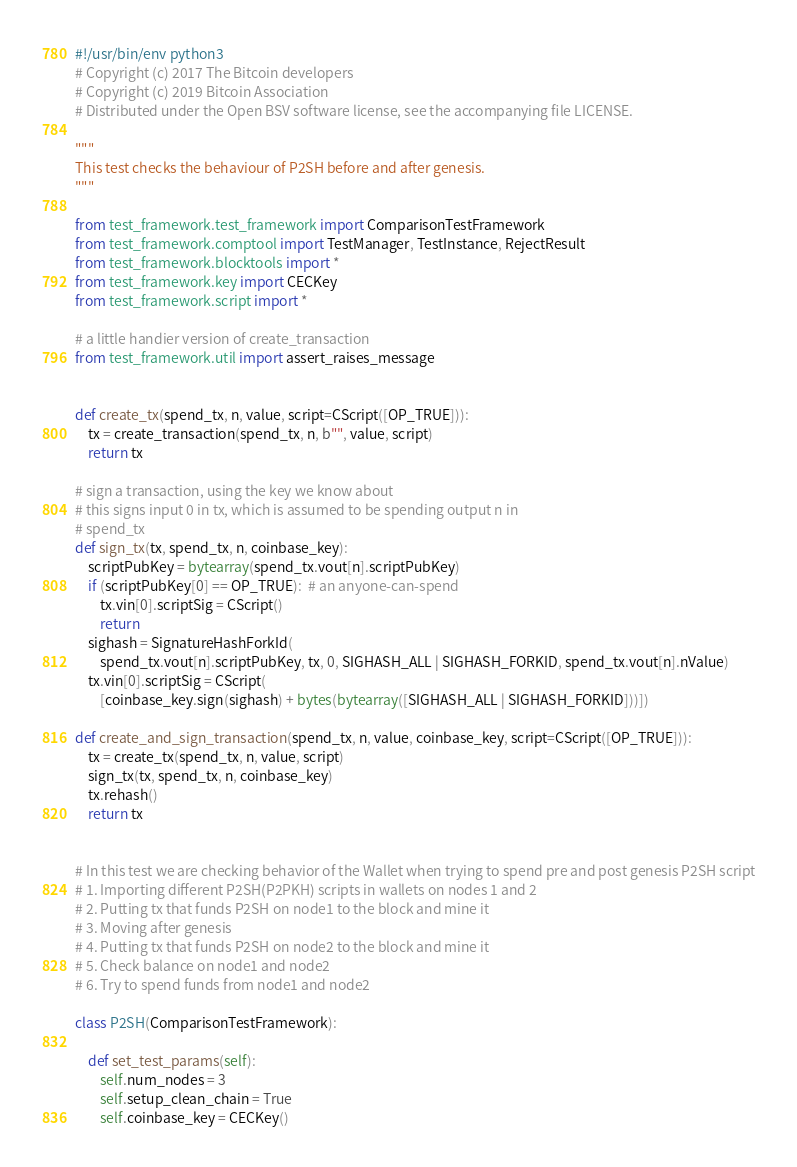<code> <loc_0><loc_0><loc_500><loc_500><_Python_>#!/usr/bin/env python3
# Copyright (c) 2017 The Bitcoin developers
# Copyright (c) 2019 Bitcoin Association
# Distributed under the Open BSV software license, see the accompanying file LICENSE.

"""
This test checks the behaviour of P2SH before and after genesis.
"""

from test_framework.test_framework import ComparisonTestFramework
from test_framework.comptool import TestManager, TestInstance, RejectResult
from test_framework.blocktools import *
from test_framework.key import CECKey
from test_framework.script import *

# a little handier version of create_transaction
from test_framework.util import assert_raises_message


def create_tx(spend_tx, n, value, script=CScript([OP_TRUE])):
    tx = create_transaction(spend_tx, n, b"", value, script)
    return tx

# sign a transaction, using the key we know about
# this signs input 0 in tx, which is assumed to be spending output n in
# spend_tx
def sign_tx(tx, spend_tx, n, coinbase_key):
    scriptPubKey = bytearray(spend_tx.vout[n].scriptPubKey)
    if (scriptPubKey[0] == OP_TRUE):  # an anyone-can-spend
        tx.vin[0].scriptSig = CScript()
        return
    sighash = SignatureHashForkId(
        spend_tx.vout[n].scriptPubKey, tx, 0, SIGHASH_ALL | SIGHASH_FORKID, spend_tx.vout[n].nValue)
    tx.vin[0].scriptSig = CScript(
        [coinbase_key.sign(sighash) + bytes(bytearray([SIGHASH_ALL | SIGHASH_FORKID]))])

def create_and_sign_transaction(spend_tx, n, value, coinbase_key, script=CScript([OP_TRUE])):
    tx = create_tx(spend_tx, n, value, script)
    sign_tx(tx, spend_tx, n, coinbase_key)
    tx.rehash()
    return tx


# In this test we are checking behavior of the Wallet when trying to spend pre and post genesis P2SH script
# 1. Importing different P2SH(P2PKH) scripts in wallets on nodes 1 and 2
# 2. Putting tx that funds P2SH on node1 to the block and mine it
# 3. Moving after genesis
# 4. Putting tx that funds P2SH on node2 to the block and mine it
# 5. Check balance on node1 and node2
# 6. Try to spend funds from node1 and node2

class P2SH(ComparisonTestFramework):

    def set_test_params(self):
        self.num_nodes = 3
        self.setup_clean_chain = True
        self.coinbase_key = CECKey()</code> 